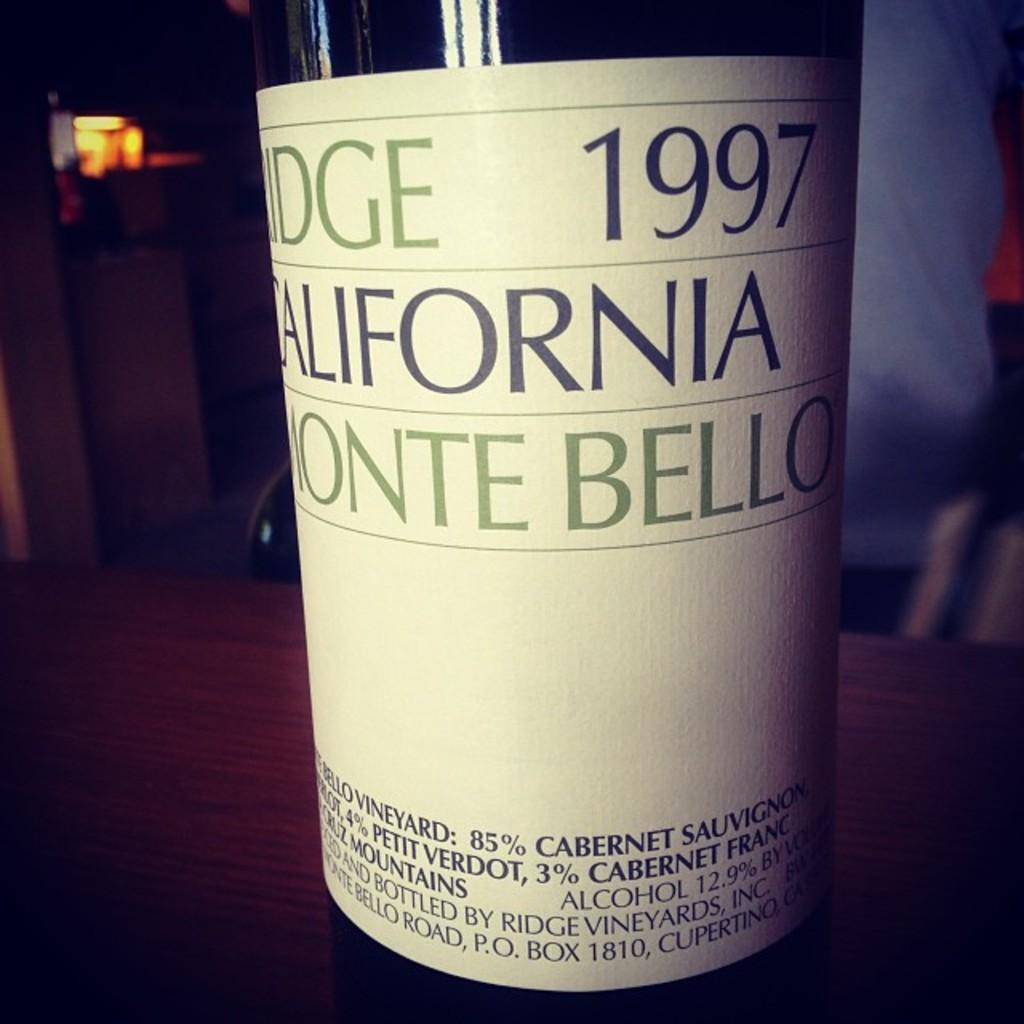What can be seen in the image? There is a bottle in the image. Where is the bottle located? The bottle is on a wooden surface. What is on the bottle? The bottle has a sticker on it. What can be seen in the background of the image? There are objects visible in the background of the image. How would you describe the lighting in the image? The background of the image is dark. What type of beam is holding up the ceiling in the image? There is no beam visible in the image, as it focuses on a bottle on a wooden surface. Can you describe the self-portrait of the person in the image? There is no person or self-portrait present in the image. 